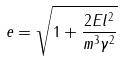<formula> <loc_0><loc_0><loc_500><loc_500>e = \sqrt { 1 + \frac { 2 E l ^ { 2 } } { m ^ { 3 } \gamma ^ { 2 } } }</formula> 